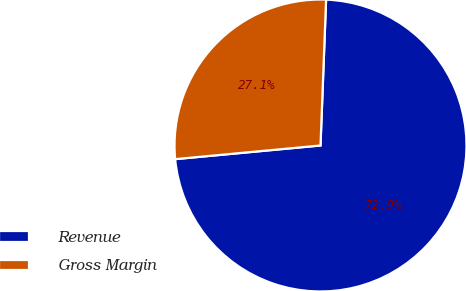<chart> <loc_0><loc_0><loc_500><loc_500><pie_chart><fcel>Revenue<fcel>Gross Margin<nl><fcel>72.9%<fcel>27.1%<nl></chart> 